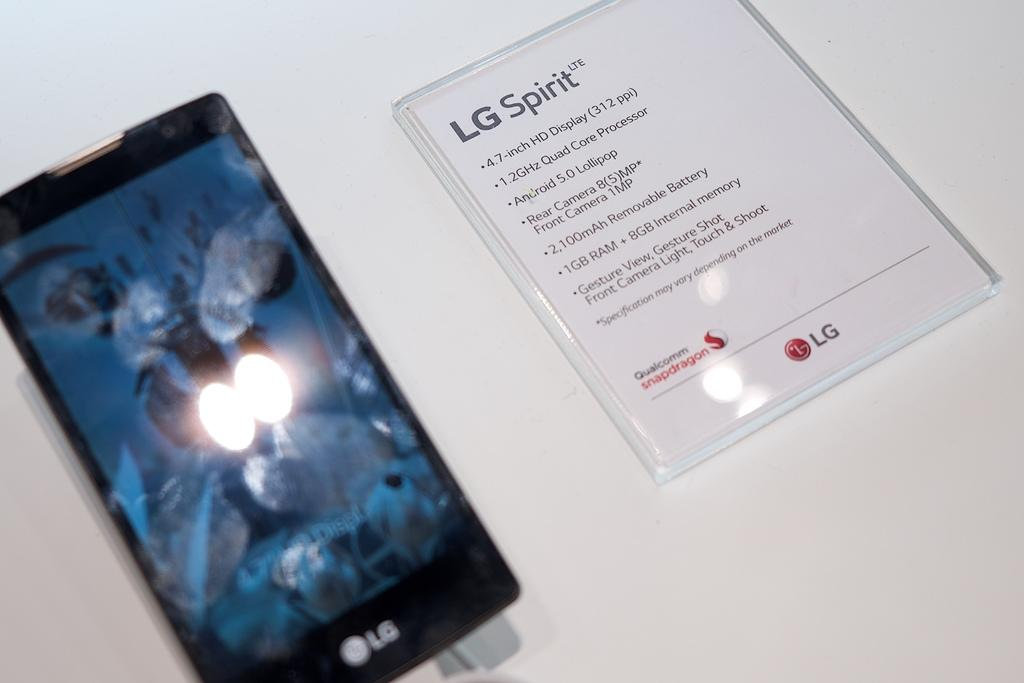What electronic device is featured in the image? There is a smartphone in the picture. What can be seen on the smartphone's display? The smartphone has a display, but the image does not show its contents. Where can the specifications of the smartphone be found in the image? The specifications are listed on the right side of the image. What is the color of the surface on which the smartphone is placed? The smartphone is placed on a white surface. What type of fairies can be seen flying around the smartphone in the image? There are no fairies present in the image; it only features a smartphone on a white surface with specifications listed on the right side. 